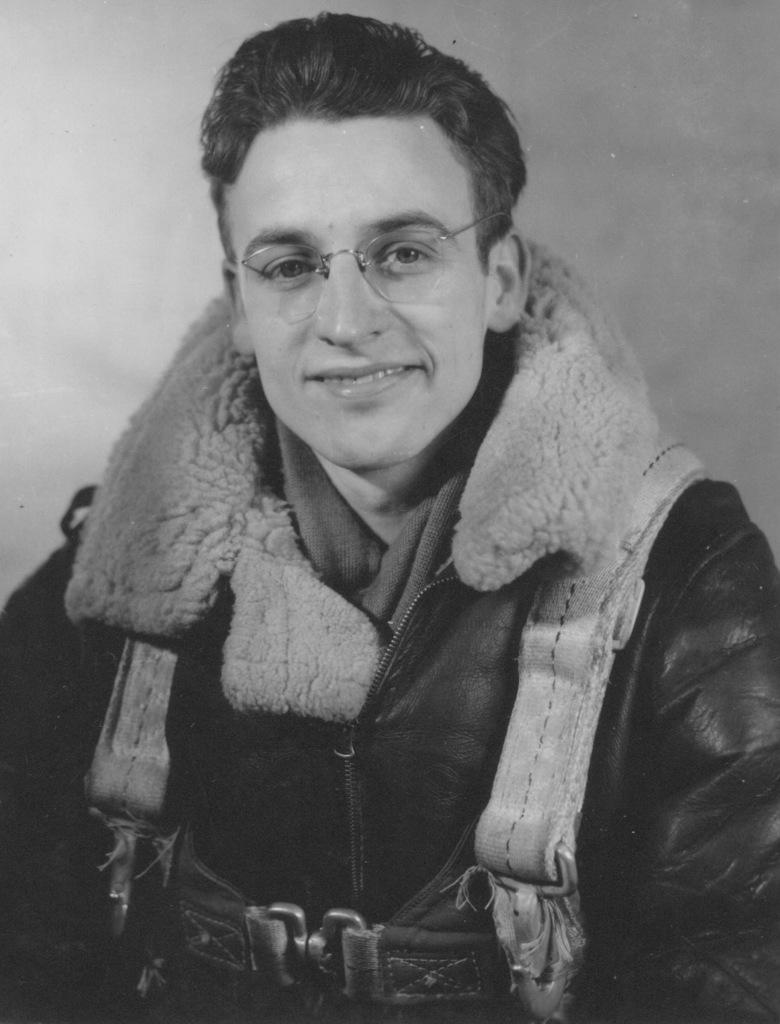Who is present in the image? There is a man in the image. What is the man wearing in the image? The man is wearing a jacket in the image. What is the man's facial expression in the image? The man is smiling in the image. What accessory is the man wearing in the image? The man is wearing spectacles in the image. What type of wax is the man using to make candles in the image? There is no wax or candles present in the image; the man is simply wearing a jacket, smiling, and wearing spectacles. 